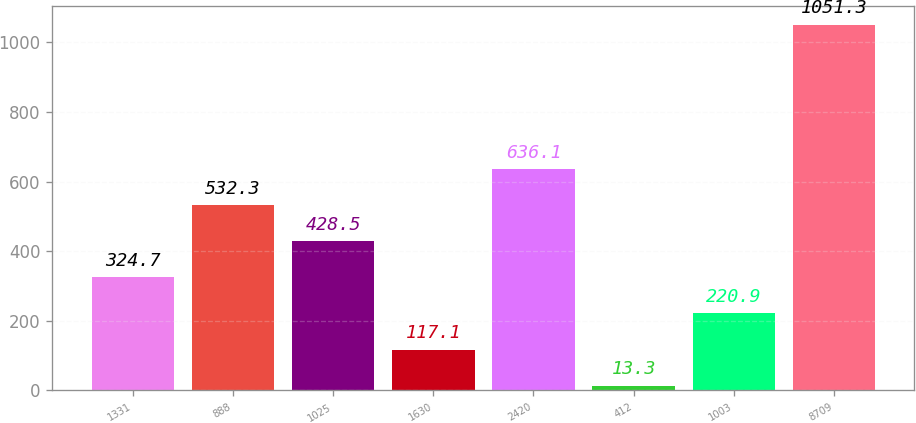Convert chart to OTSL. <chart><loc_0><loc_0><loc_500><loc_500><bar_chart><fcel>1331<fcel>888<fcel>1025<fcel>1630<fcel>2420<fcel>412<fcel>1003<fcel>8709<nl><fcel>324.7<fcel>532.3<fcel>428.5<fcel>117.1<fcel>636.1<fcel>13.3<fcel>220.9<fcel>1051.3<nl></chart> 